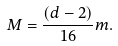Convert formula to latex. <formula><loc_0><loc_0><loc_500><loc_500>M = \frac { \left ( d - 2 \right ) } { 1 6 } m .</formula> 